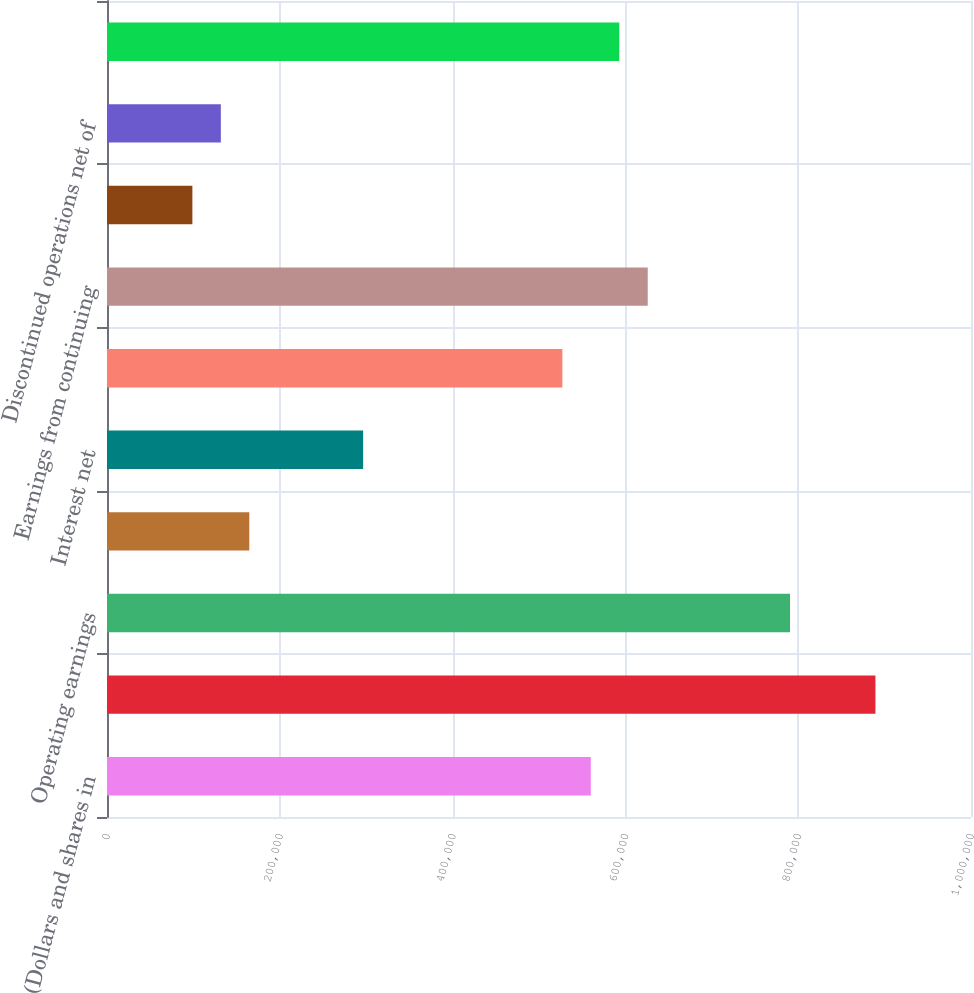Convert chart to OTSL. <chart><loc_0><loc_0><loc_500><loc_500><bar_chart><fcel>(Dollars and shares in<fcel>Revenues<fcel>Operating earnings<fcel>Operating margin<fcel>Interest net<fcel>Provision for income taxes net<fcel>Earnings from continuing<fcel>Return on sales (a)<fcel>Discontinued operations net of<fcel>Net earnings<nl><fcel>559979<fcel>889378<fcel>790558<fcel>164701<fcel>296460<fcel>527039<fcel>625859<fcel>98820.8<fcel>131761<fcel>592919<nl></chart> 